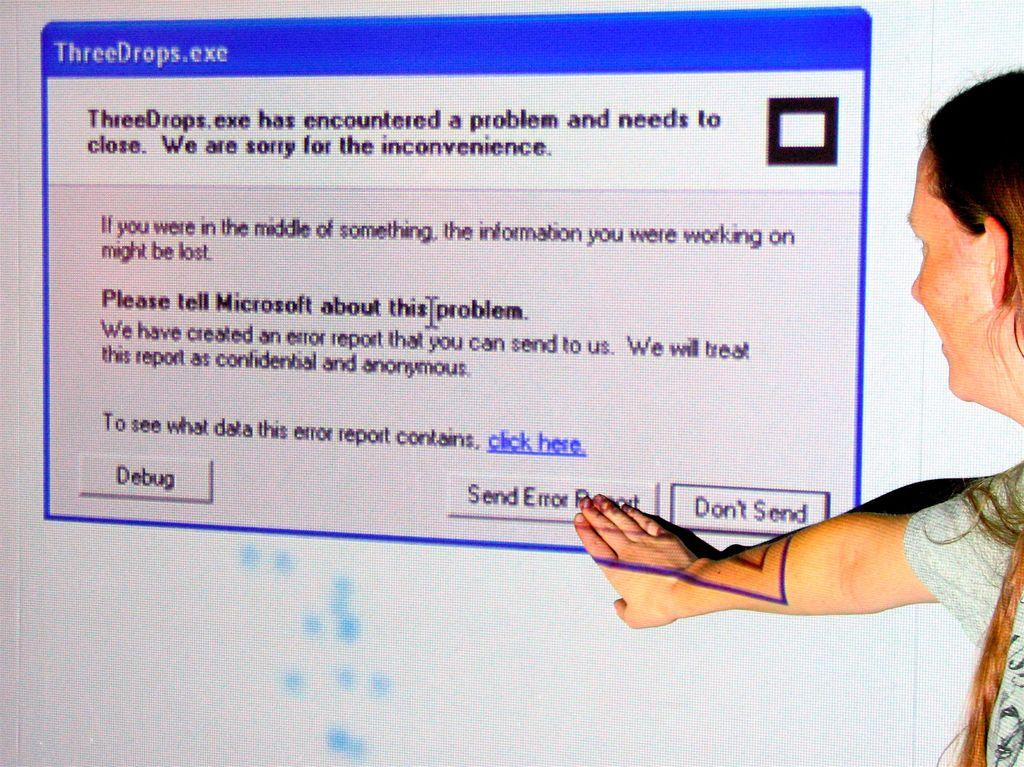What is the lady doing in the image? The lady is standing in the image with her hand placed on a screen. What can be seen on the screen? There is text visible on the screen. What type of glue is the lady using to attach the zipper in the image? There is no glue or zipper present in the image; the lady is simply standing with her hand on a screen. 